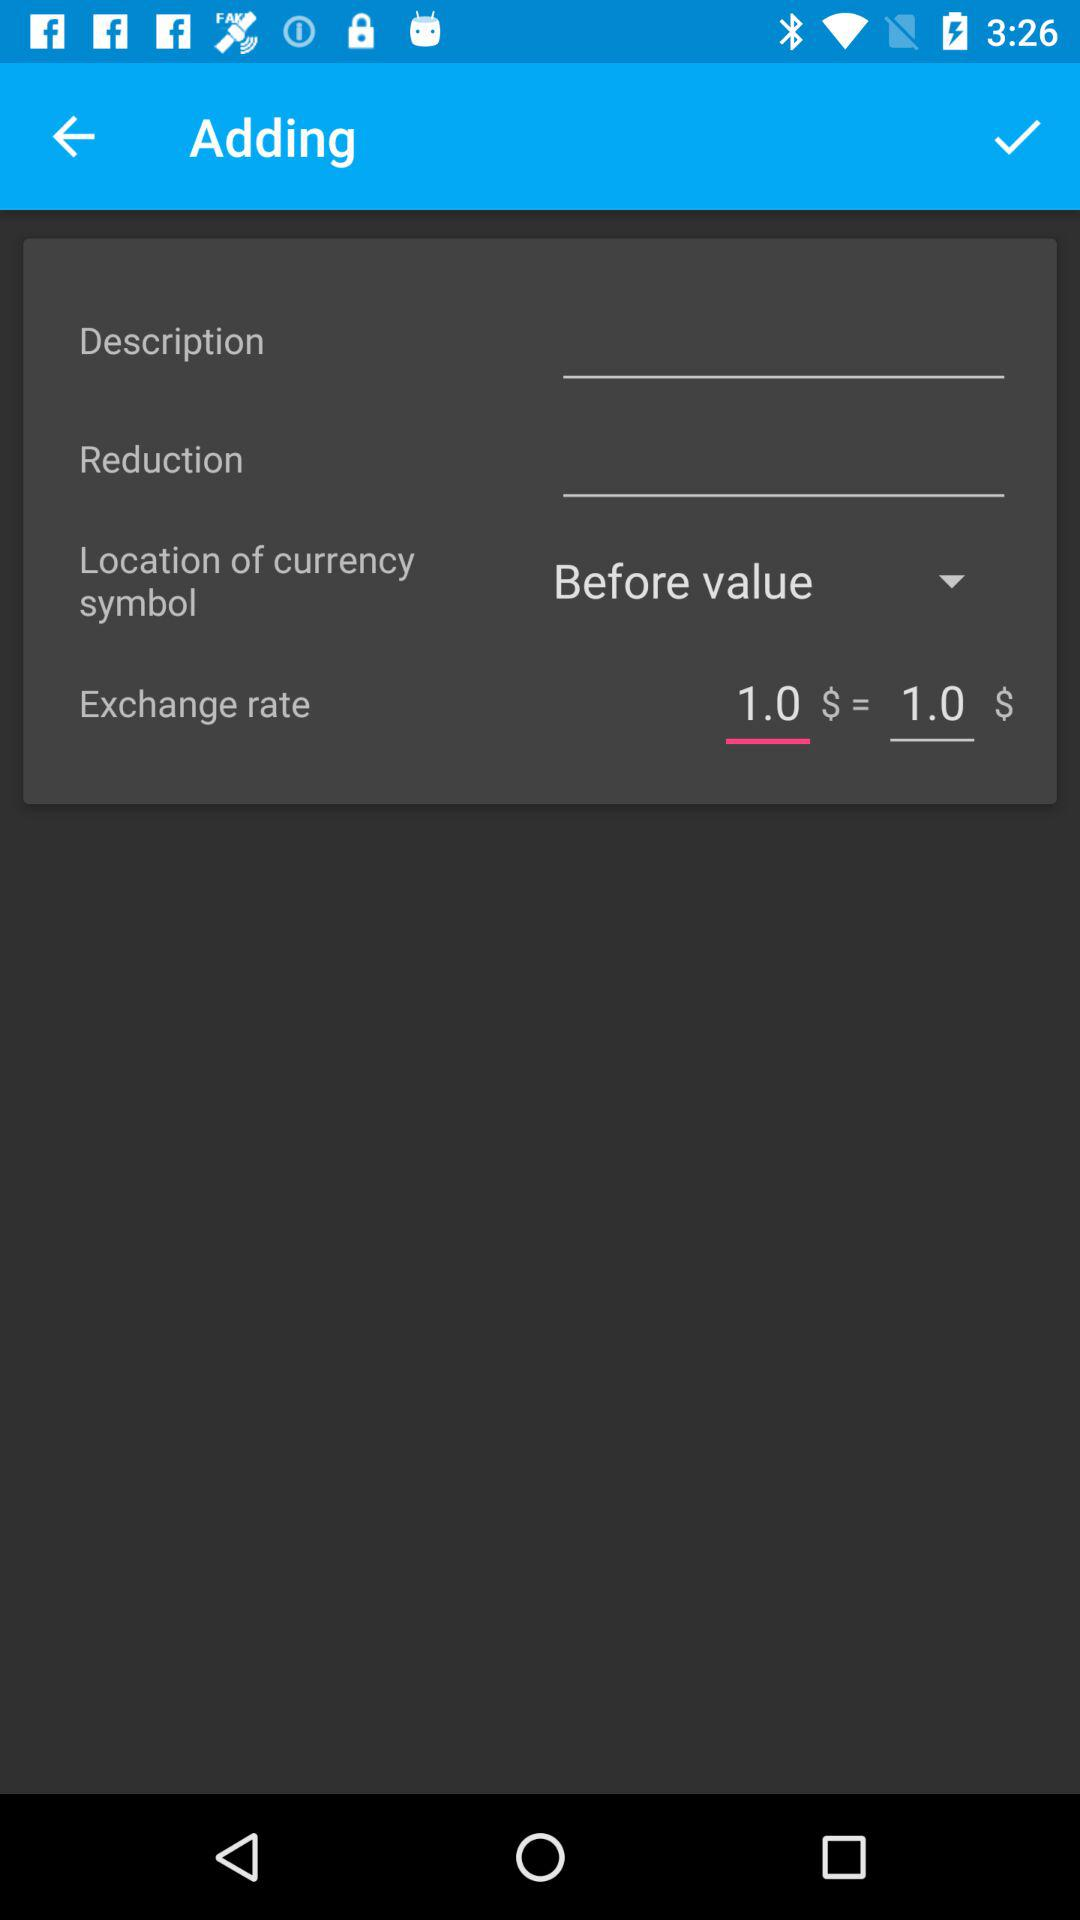What is the location of the currency symbol? The location of the currency symbol is before the value. 